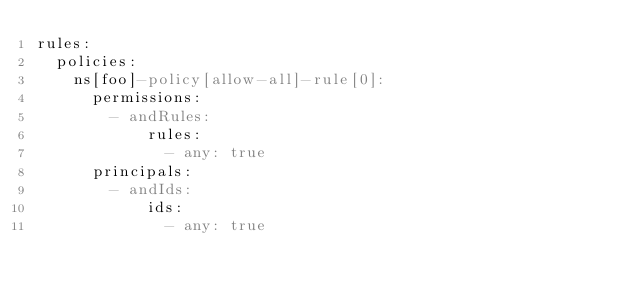<code> <loc_0><loc_0><loc_500><loc_500><_YAML_>rules:
  policies:
    ns[foo]-policy[allow-all]-rule[0]:
      permissions:
        - andRules:
            rules:
              - any: true
      principals:
        - andIds:
            ids:
              - any: true
</code> 